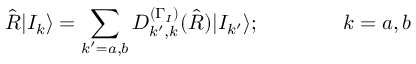Convert formula to latex. <formula><loc_0><loc_0><loc_500><loc_500>\hat { R } | I _ { k } \rangle = \sum _ { k ^ { \prime } = a , b } D _ { k ^ { \prime } , k } ^ { ( \Gamma _ { I } ) } ( \hat { R } ) | I _ { k ^ { \prime } } \rangle ; \quad k = a , b</formula> 